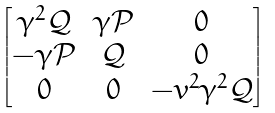<formula> <loc_0><loc_0><loc_500><loc_500>\begin{bmatrix} \gamma ^ { 2 } \mathcal { Q } & \gamma \mathcal { P } & 0 \\ - \gamma \mathcal { P } & \mathcal { Q } & 0 \\ 0 & 0 & - v ^ { 2 } \gamma ^ { 2 } \mathcal { Q } \end{bmatrix}</formula> 